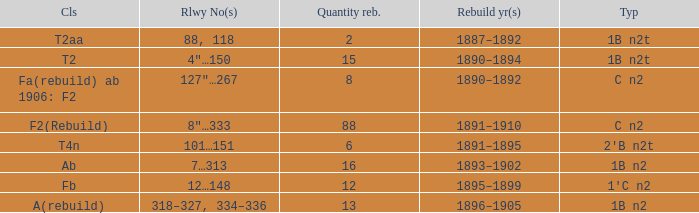What is the type if quantity rebuilt is more than 2 and the railway number is 4"…150? 1B n2t. 